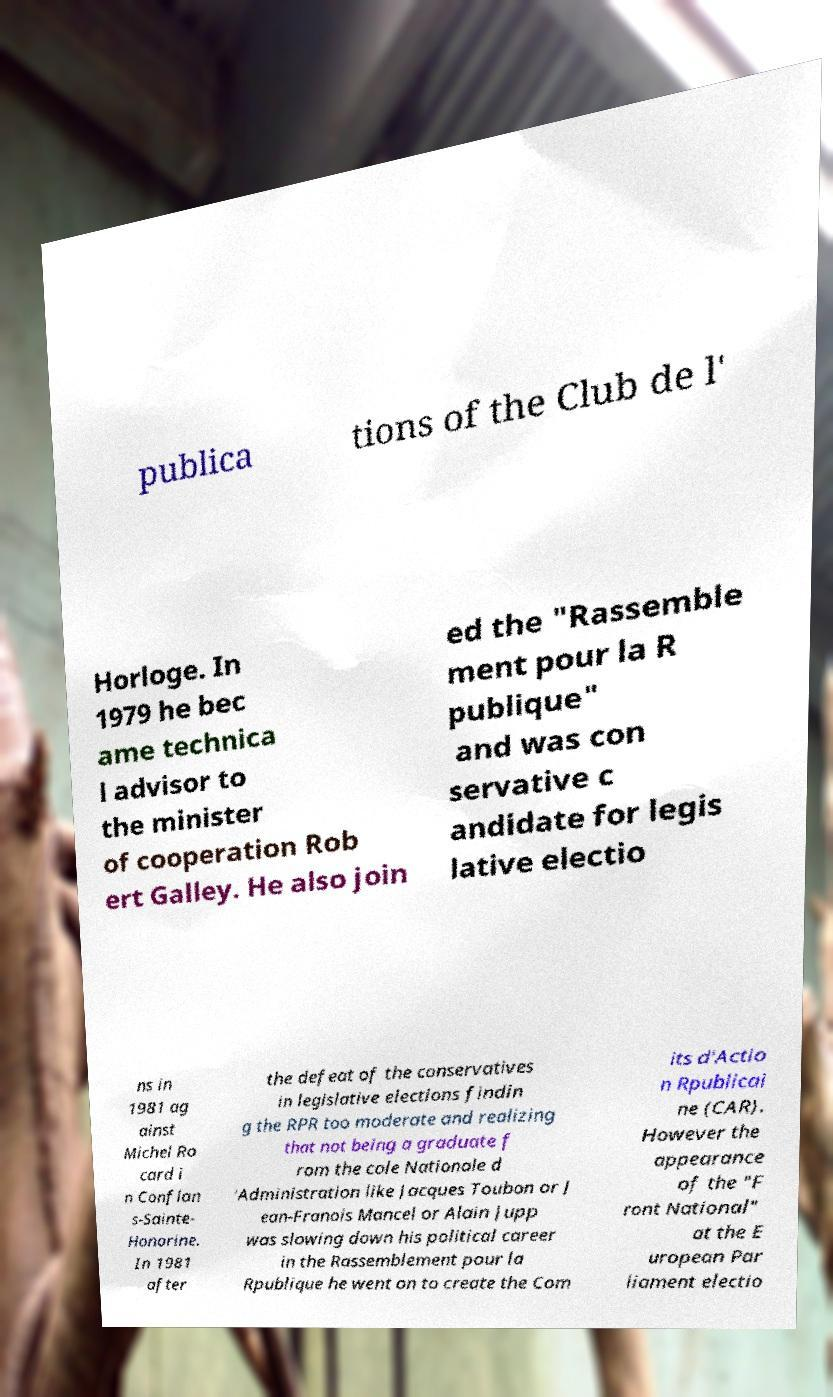Can you accurately transcribe the text from the provided image for me? publica tions of the Club de l' Horloge. In 1979 he bec ame technica l advisor to the minister of cooperation Rob ert Galley. He also join ed the "Rassemble ment pour la R publique" and was con servative c andidate for legis lative electio ns in 1981 ag ainst Michel Ro card i n Conflan s-Sainte- Honorine. In 1981 after the defeat of the conservatives in legislative elections findin g the RPR too moderate and realizing that not being a graduate f rom the cole Nationale d 'Administration like Jacques Toubon or J ean-Franois Mancel or Alain Jupp was slowing down his political career in the Rassemblement pour la Rpublique he went on to create the Com its d'Actio n Rpublicai ne (CAR). However the appearance of the "F ront National" at the E uropean Par liament electio 